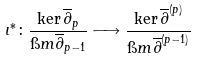Convert formula to latex. <formula><loc_0><loc_0><loc_500><loc_500>\iota ^ { \ast } \colon \frac { \ker \overline { \partial } _ { p } } { \i m \overline { \partial } _ { p - 1 } } \longrightarrow \frac { \ker \overline { \partial } ^ { ( p ) } } { \i m \overline { \partial } ^ { ( p - 1 ) } }</formula> 